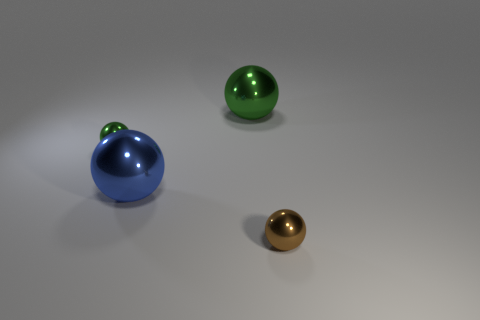Add 1 big gray rubber cubes. How many objects exist? 5 Subtract all tiny brown shiny balls. How many balls are left? 3 Subtract all green balls. How many balls are left? 2 Subtract 4 balls. How many balls are left? 0 Add 1 small brown metallic balls. How many small brown metallic balls are left? 2 Add 3 large green shiny spheres. How many large green shiny spheres exist? 4 Subtract 0 red spheres. How many objects are left? 4 Subtract all blue balls. Subtract all cyan cylinders. How many balls are left? 3 Subtract all blue cubes. How many brown spheres are left? 1 Subtract all tiny green things. Subtract all brown things. How many objects are left? 2 